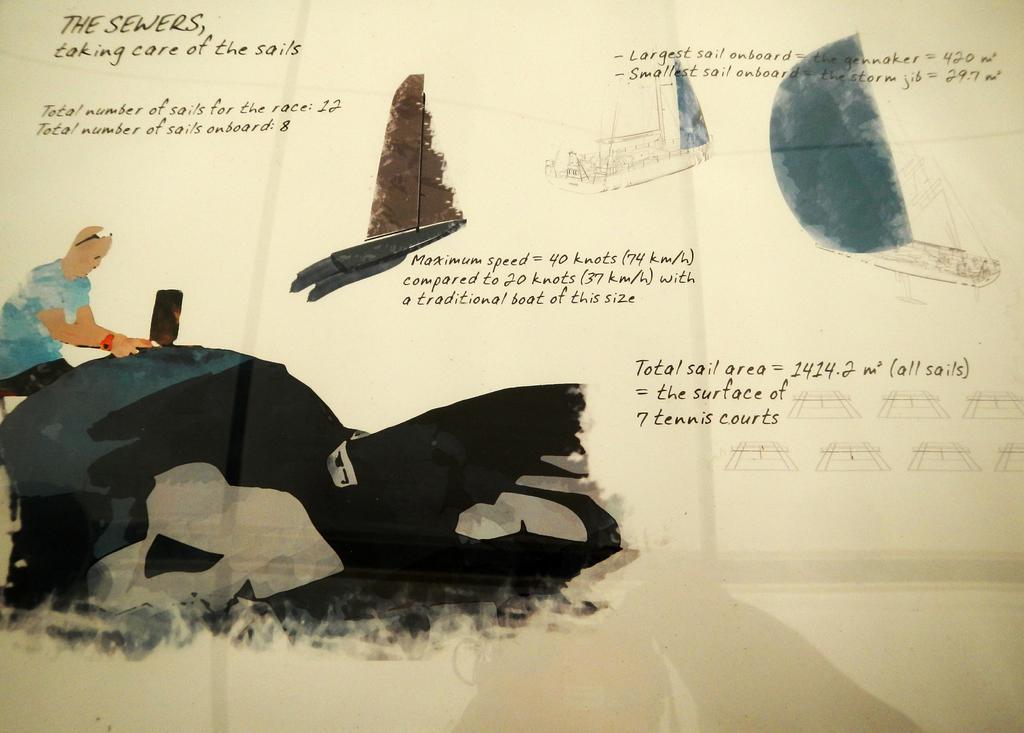How would you summarize this image in a sentence or two? This is a poster,in this picture we can see a person and boats. 